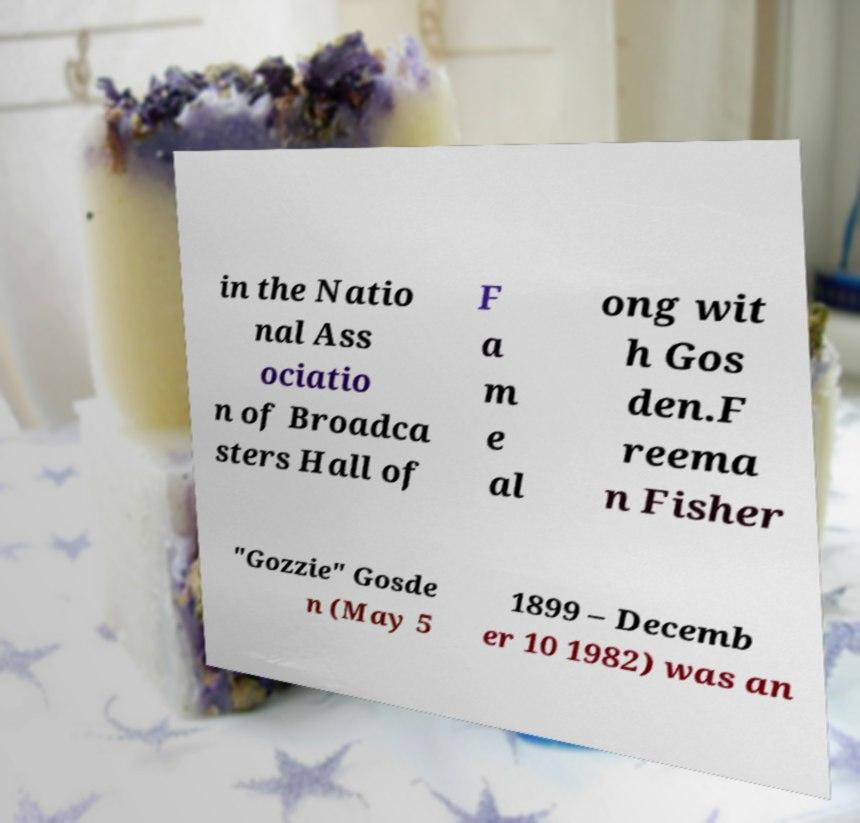Could you assist in decoding the text presented in this image and type it out clearly? in the Natio nal Ass ociatio n of Broadca sters Hall of F a m e al ong wit h Gos den.F reema n Fisher "Gozzie" Gosde n (May 5 1899 – Decemb er 10 1982) was an 